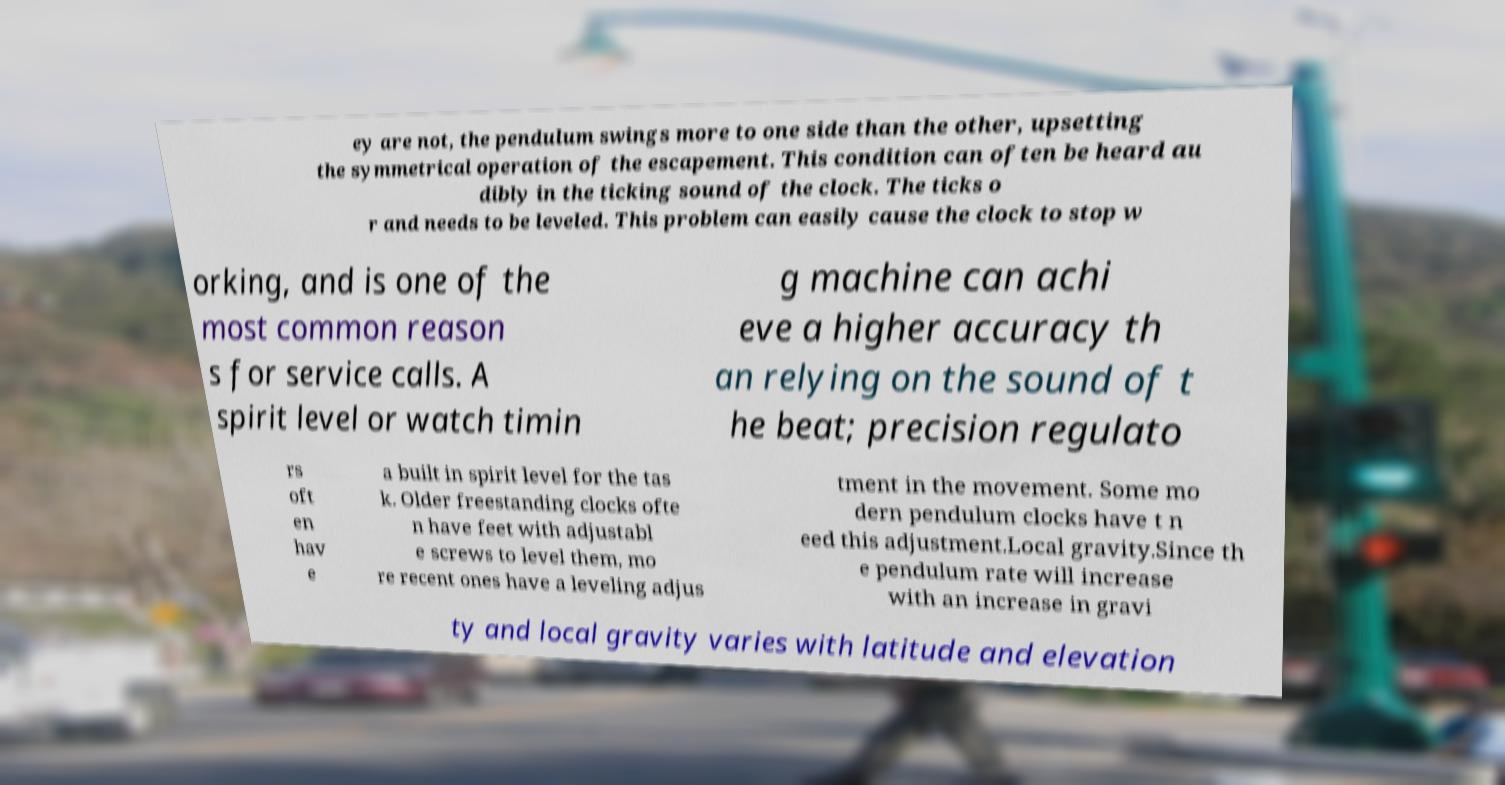Please identify and transcribe the text found in this image. ey are not, the pendulum swings more to one side than the other, upsetting the symmetrical operation of the escapement. This condition can often be heard au dibly in the ticking sound of the clock. The ticks o r and needs to be leveled. This problem can easily cause the clock to stop w orking, and is one of the most common reason s for service calls. A spirit level or watch timin g machine can achi eve a higher accuracy th an relying on the sound of t he beat; precision regulato rs oft en hav e a built in spirit level for the tas k. Older freestanding clocks ofte n have feet with adjustabl e screws to level them, mo re recent ones have a leveling adjus tment in the movement. Some mo dern pendulum clocks have t n eed this adjustment.Local gravity.Since th e pendulum rate will increase with an increase in gravi ty and local gravity varies with latitude and elevation 